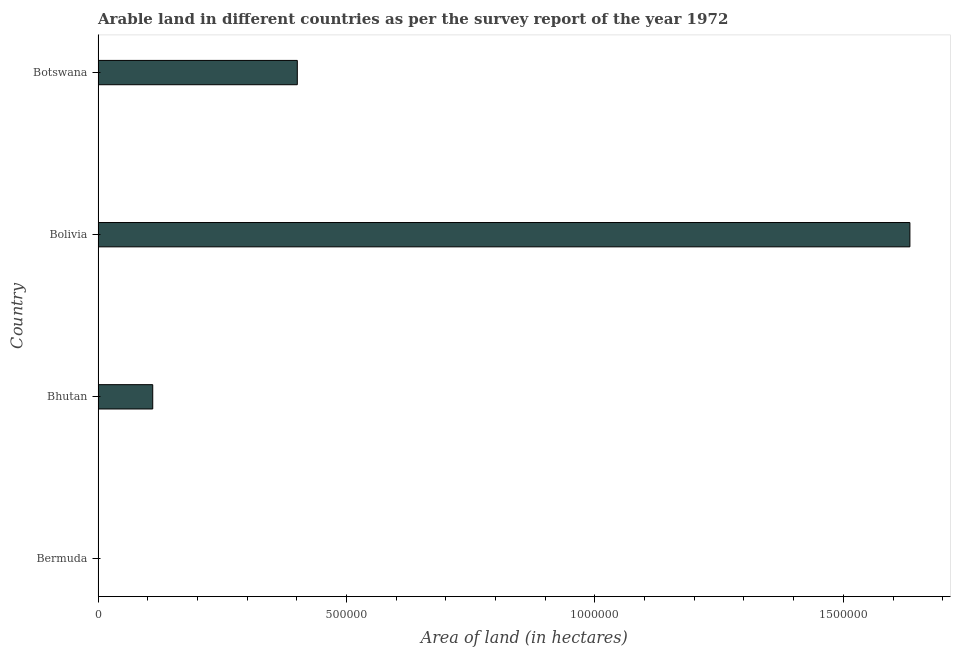Does the graph contain grids?
Make the answer very short. No. What is the title of the graph?
Ensure brevity in your answer.  Arable land in different countries as per the survey report of the year 1972. What is the label or title of the X-axis?
Ensure brevity in your answer.  Area of land (in hectares). What is the area of land in Botswana?
Provide a short and direct response. 4.01e+05. Across all countries, what is the maximum area of land?
Keep it short and to the point. 1.63e+06. Across all countries, what is the minimum area of land?
Your response must be concise. 300. In which country was the area of land maximum?
Give a very brief answer. Bolivia. In which country was the area of land minimum?
Offer a very short reply. Bermuda. What is the sum of the area of land?
Offer a very short reply. 2.15e+06. What is the difference between the area of land in Bermuda and Bolivia?
Offer a very short reply. -1.63e+06. What is the average area of land per country?
Make the answer very short. 5.36e+05. What is the median area of land?
Give a very brief answer. 2.56e+05. In how many countries, is the area of land greater than 1500000 hectares?
Offer a very short reply. 1. What is the ratio of the area of land in Bermuda to that in Bhutan?
Keep it short and to the point. 0. Is the difference between the area of land in Bermuda and Botswana greater than the difference between any two countries?
Give a very brief answer. No. What is the difference between the highest and the second highest area of land?
Give a very brief answer. 1.23e+06. Is the sum of the area of land in Bermuda and Bhutan greater than the maximum area of land across all countries?
Make the answer very short. No. What is the difference between the highest and the lowest area of land?
Make the answer very short. 1.63e+06. In how many countries, is the area of land greater than the average area of land taken over all countries?
Your answer should be very brief. 1. How many bars are there?
Offer a very short reply. 4. What is the difference between two consecutive major ticks on the X-axis?
Your answer should be compact. 5.00e+05. Are the values on the major ticks of X-axis written in scientific E-notation?
Your response must be concise. No. What is the Area of land (in hectares) of Bermuda?
Your answer should be very brief. 300. What is the Area of land (in hectares) of Bolivia?
Offer a very short reply. 1.63e+06. What is the Area of land (in hectares) of Botswana?
Your answer should be compact. 4.01e+05. What is the difference between the Area of land (in hectares) in Bermuda and Bhutan?
Your response must be concise. -1.10e+05. What is the difference between the Area of land (in hectares) in Bermuda and Bolivia?
Your response must be concise. -1.63e+06. What is the difference between the Area of land (in hectares) in Bermuda and Botswana?
Keep it short and to the point. -4.01e+05. What is the difference between the Area of land (in hectares) in Bhutan and Bolivia?
Offer a terse response. -1.52e+06. What is the difference between the Area of land (in hectares) in Bhutan and Botswana?
Offer a very short reply. -2.91e+05. What is the difference between the Area of land (in hectares) in Bolivia and Botswana?
Give a very brief answer. 1.23e+06. What is the ratio of the Area of land (in hectares) in Bermuda to that in Bhutan?
Your answer should be compact. 0. What is the ratio of the Area of land (in hectares) in Bhutan to that in Bolivia?
Give a very brief answer. 0.07. What is the ratio of the Area of land (in hectares) in Bhutan to that in Botswana?
Provide a succinct answer. 0.27. What is the ratio of the Area of land (in hectares) in Bolivia to that in Botswana?
Provide a succinct answer. 4.08. 